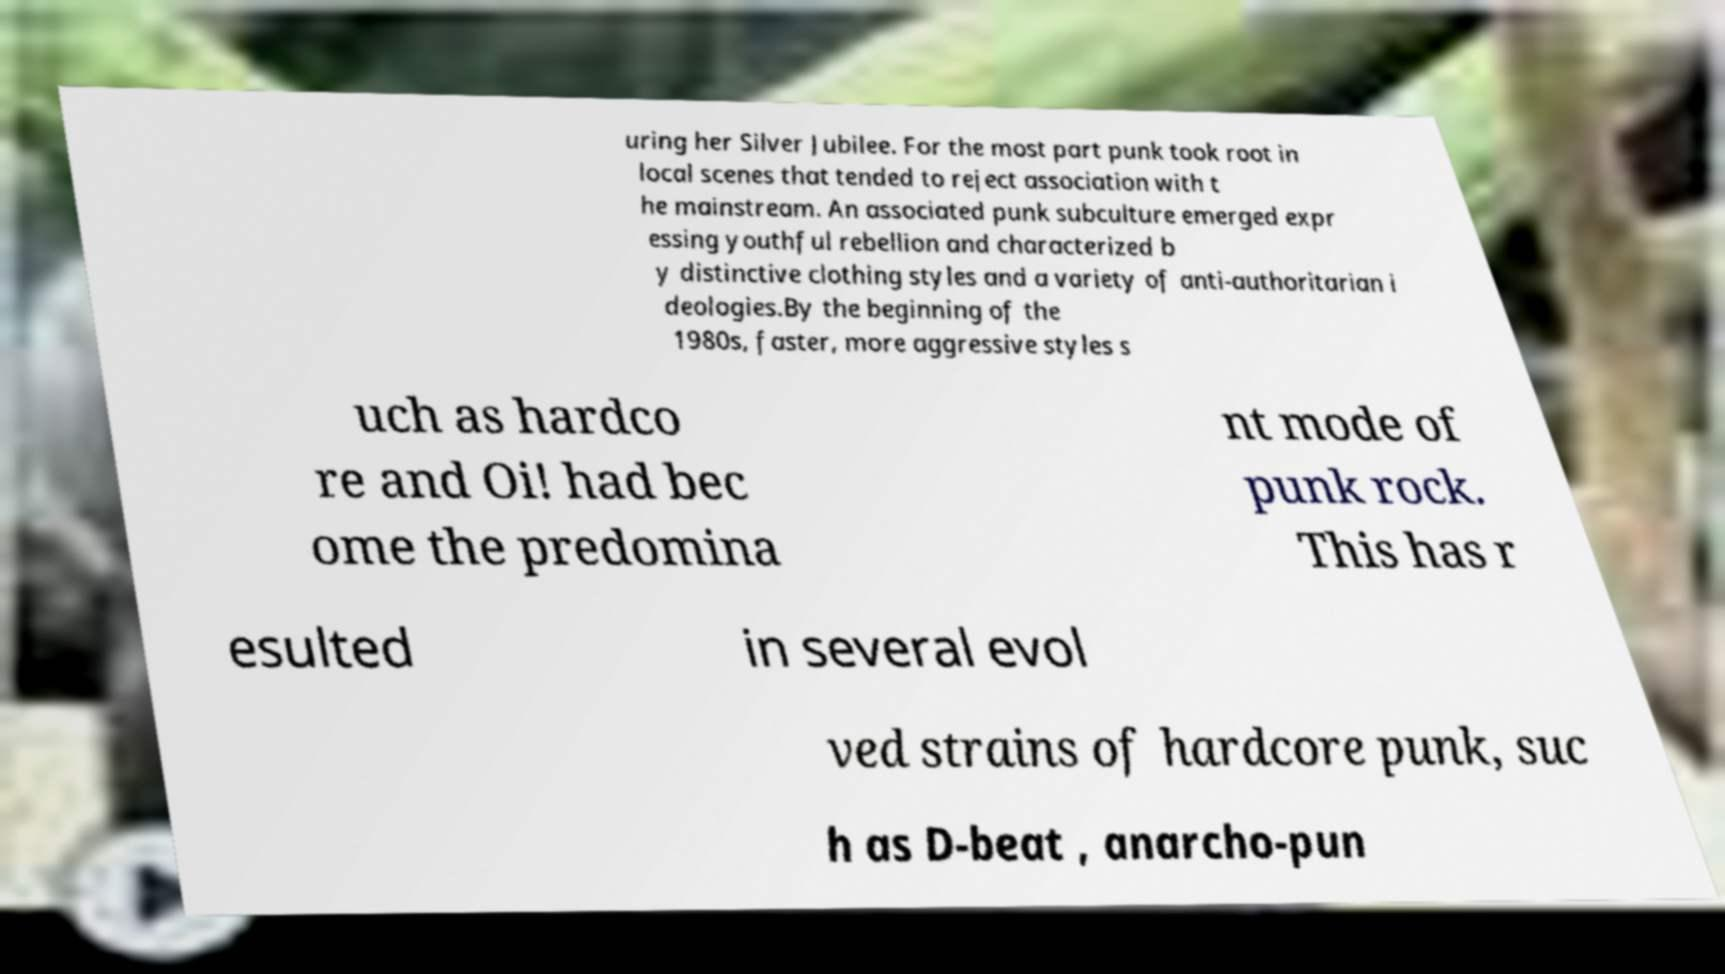For documentation purposes, I need the text within this image transcribed. Could you provide that? uring her Silver Jubilee. For the most part punk took root in local scenes that tended to reject association with t he mainstream. An associated punk subculture emerged expr essing youthful rebellion and characterized b y distinctive clothing styles and a variety of anti-authoritarian i deologies.By the beginning of the 1980s, faster, more aggressive styles s uch as hardco re and Oi! had bec ome the predomina nt mode of punk rock. This has r esulted in several evol ved strains of hardcore punk, suc h as D-beat , anarcho-pun 